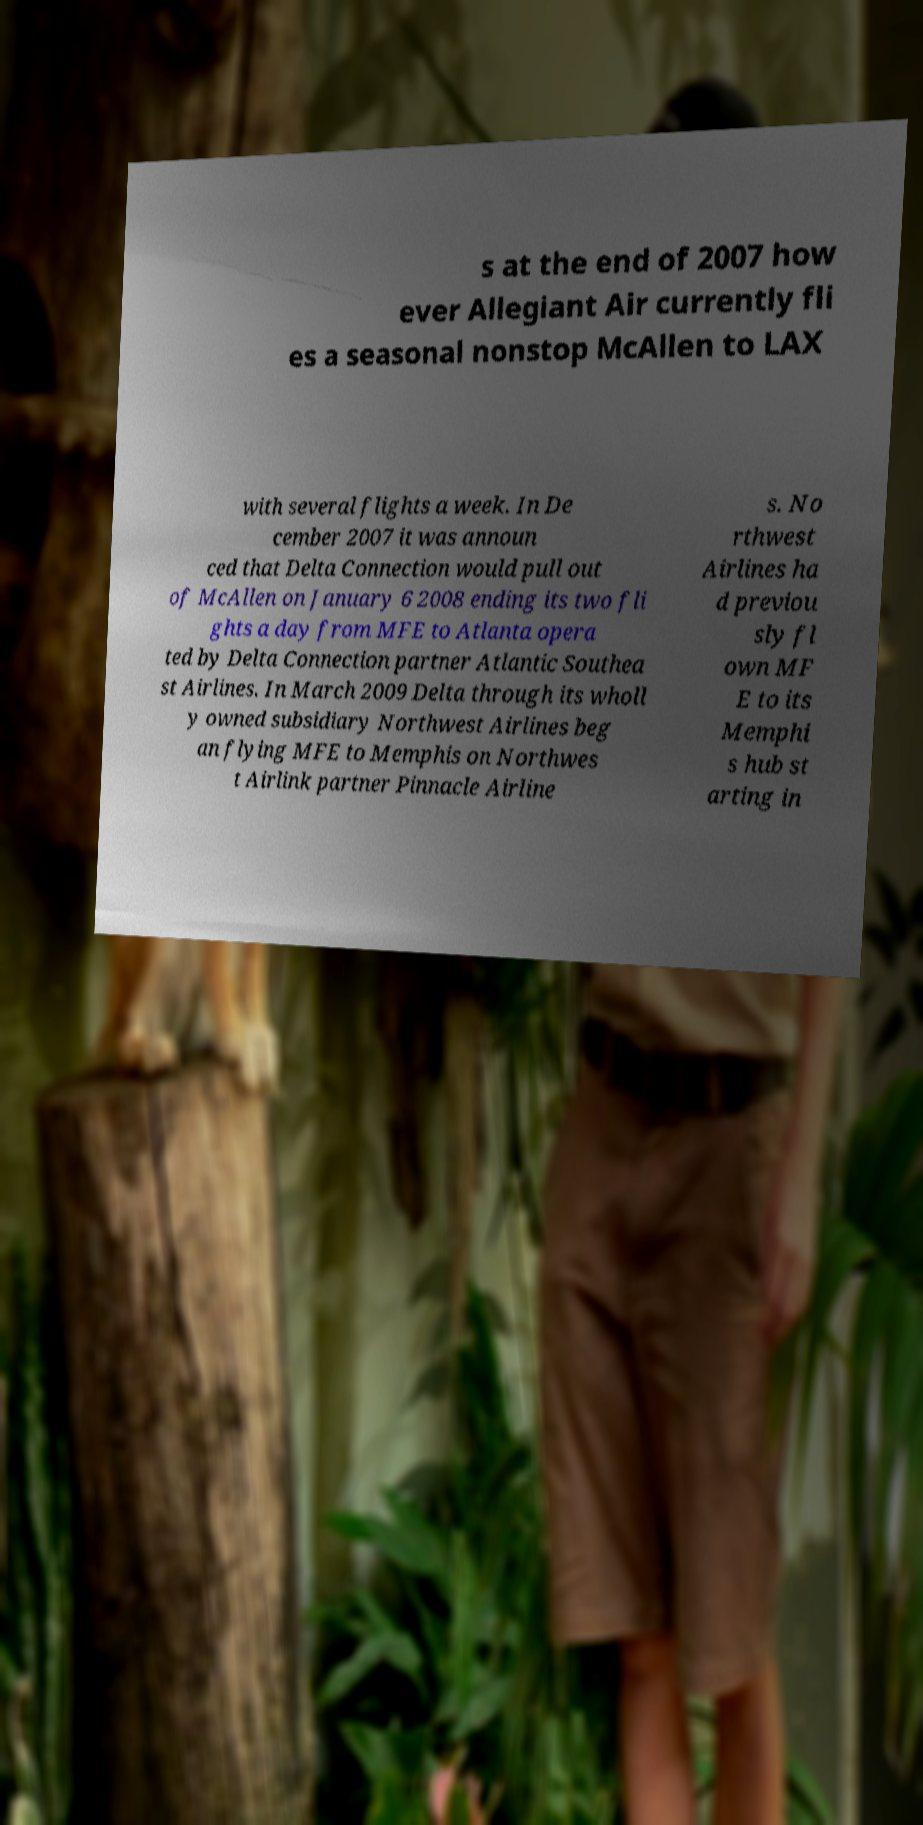Could you extract and type out the text from this image? s at the end of 2007 how ever Allegiant Air currently fli es a seasonal nonstop McAllen to LAX with several flights a week. In De cember 2007 it was announ ced that Delta Connection would pull out of McAllen on January 6 2008 ending its two fli ghts a day from MFE to Atlanta opera ted by Delta Connection partner Atlantic Southea st Airlines. In March 2009 Delta through its wholl y owned subsidiary Northwest Airlines beg an flying MFE to Memphis on Northwes t Airlink partner Pinnacle Airline s. No rthwest Airlines ha d previou sly fl own MF E to its Memphi s hub st arting in 